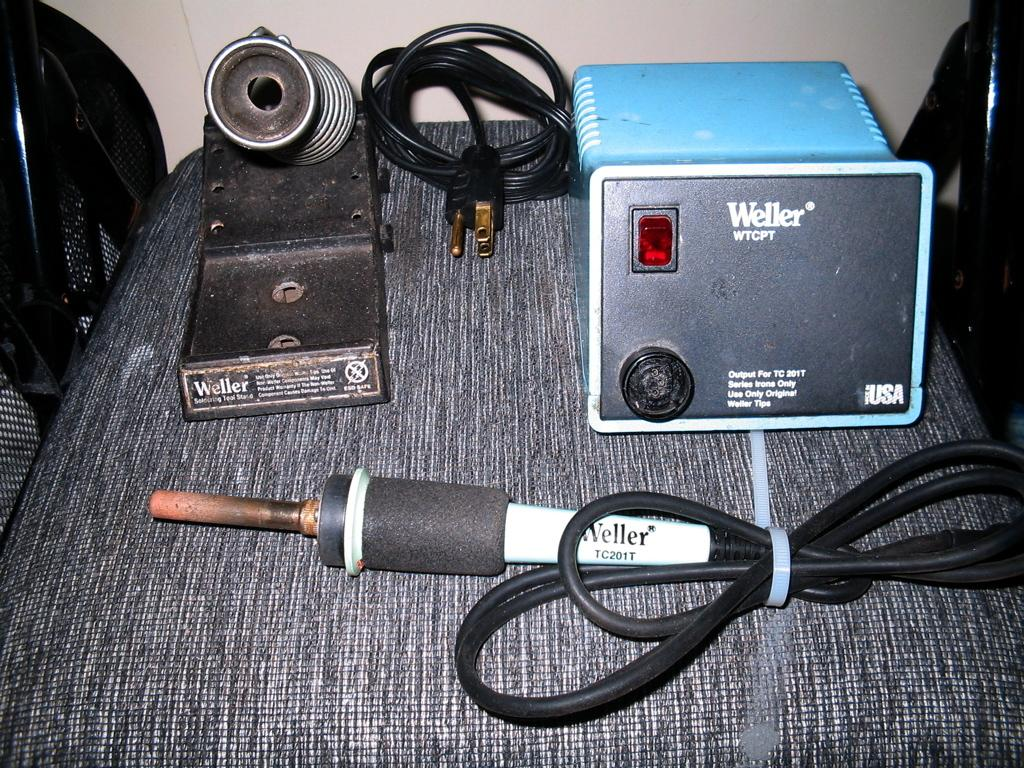What piece of furniture is present in the image? There is a table in the image. What is placed on the table? There is a black and blue color object and an electric object on the table. Can you describe the black color object on the table? It is a cable. What type of object is electric in nature? There is an electric object on the table, but its specific identity is not mentioned in the facts. What type of net is being used to catch the electric object on the table? There is no net present in the image, and the electric object is not being caught. 